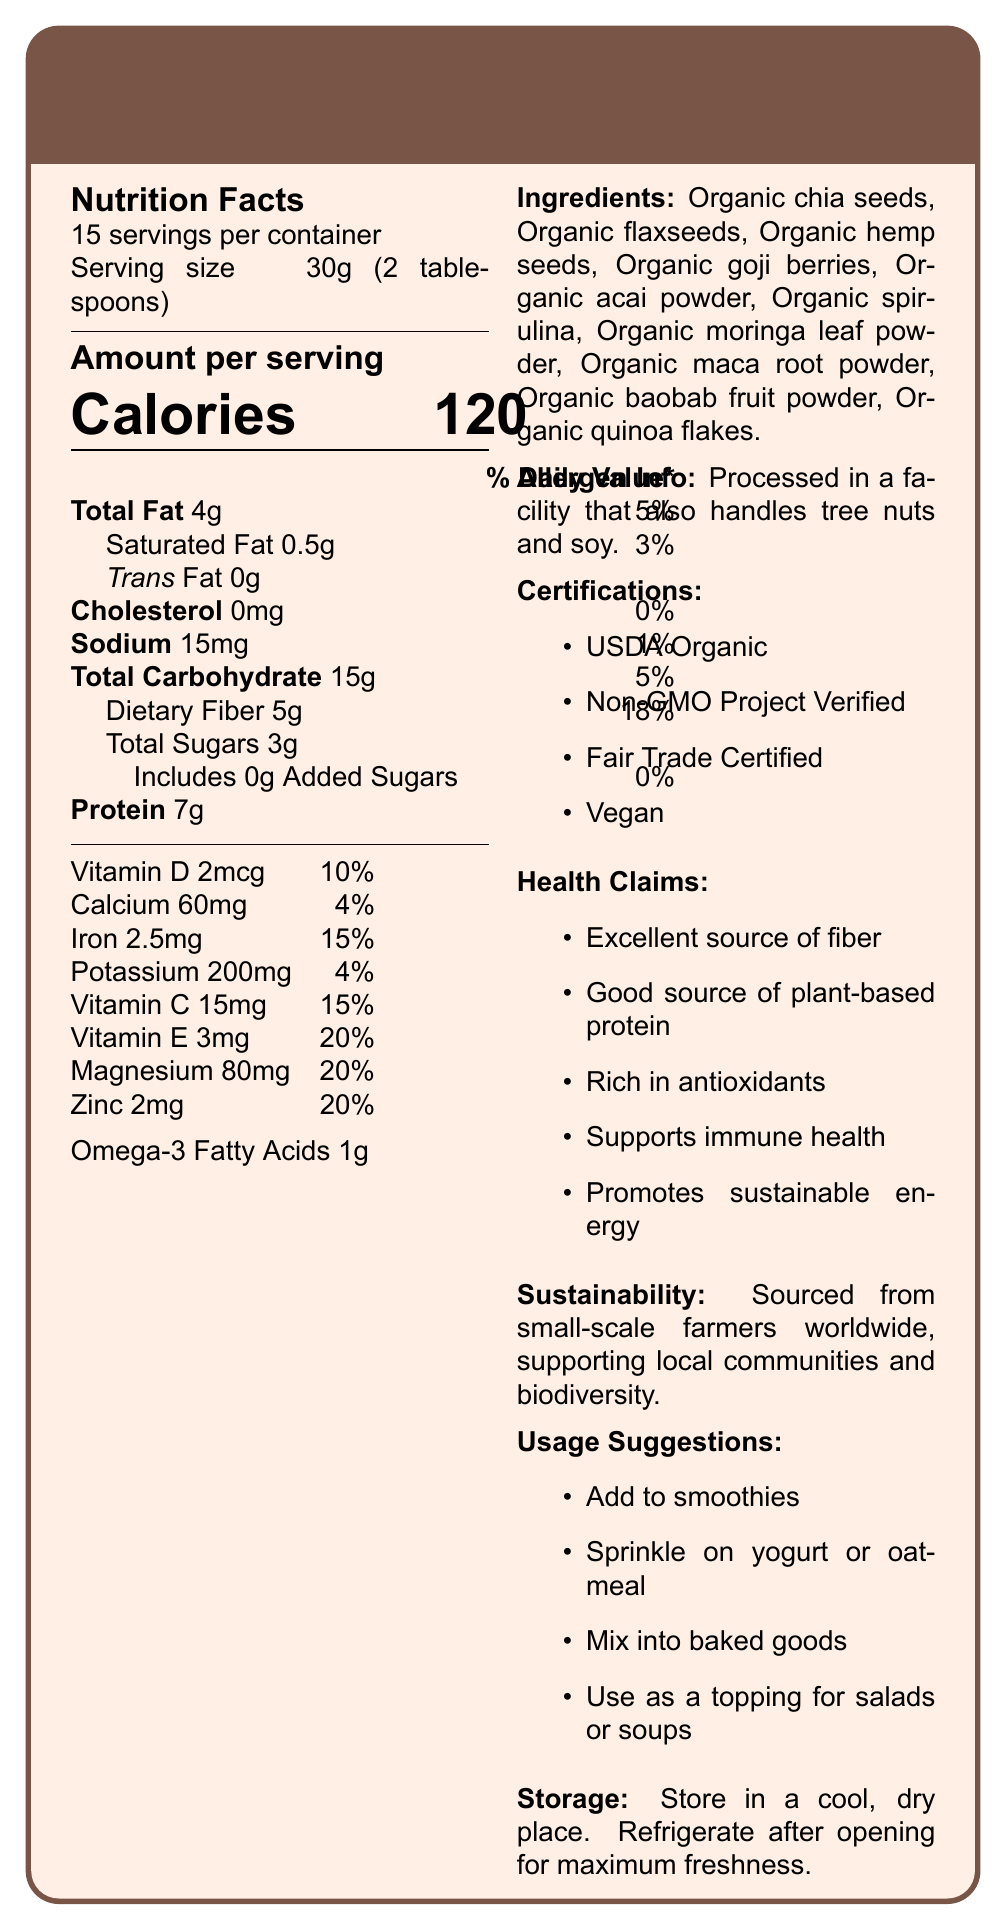what is the serving size of the Global Harmony Superfood Blend? The serving size is clearly stated in the document as 30g, equivalent to 2 tablespoons.
Answer: 30g (2 tablespoons) how many servings are there per container? According to the document, there are 15 servings per container.
Answer: 15 how much dietary fiber does one serving contain? The document specifies that each serving has 5g of dietary fiber.
Answer: 5g is this product organic? The product is USDA Organic certified, as listed among its certifications.
Answer: Yes what is the percentage daily value of iron in one serving? The document states that one serving contains 15% of the daily value of iron.
Answer: 15% which ingredient is not listed: Organic chia seeds, Organic quinoa flakes, or Organic apples? The ingredients listed do not include Organic apples, but do include Organic chia seeds and Organic quinoa flakes.
Answer: Organic apples how should the product be stored after opening? A. In a dry place B. In a humid place C. Refrigerate The storage instructions advise refrigerating the product after opening for maximum freshness.
Answer: C. Refrigerate how many calories are in one serving of the Global Harmony Superfood Blend? A. 90 B. 100 C. 120 D. 150 Each serving contains 120 calories, as clearly indicated in the document.
Answer: C. 120 are there any certification mentions regarding GMO? The product is Non-GMO Project Verified, as listed in the certifications.
Answer: Yes how does this product support global health? The sustainability statement in the document explains that the product supports global health by sourcing from small-scale farmers and promoting biodiversity.
Answer: Sourced from small-scale farmers worldwide, supporting local communities and biodiversity does the blend contain any trans fat? The document states that it contains 0g of trans fat.
Answer: No what are the health claims associated with this product? The health claims listed in the document cover these benefits.
Answer: Excellent source of fiber, Good source of plant-based protein, Rich in antioxidants, Supports immune health, Promotes sustainable energy what is the main idea of the document? The document's primary purpose is to inform about the product's nutritional content, health benefits, and certifications, emphasizing its global health and sustainability focus.
Answer: The document provides nutritional information, ingredients, health claims, certifications, and usage suggestions for the Global Harmony Superfood Blend, a nutrient-dense, multicultural superfood mix promoting global health and sustainability. is there any caffeine in the Global Harmony Superfood Blend? The document does not provide information about caffeine content.
Answer: Cannot be determined does the product promote immune health? One of the health claims specifically mentions that the product supports immune health.
Answer: Yes which certification is not held by the product: USDA Organic, Fair Trade Certified, Gluten-Free, or Vegan? The document includes USDA Organic, Fair Trade Certified, and Vegan certifications, but does not mention a Gluten-Free certification.
Answer: Gluten-Free 